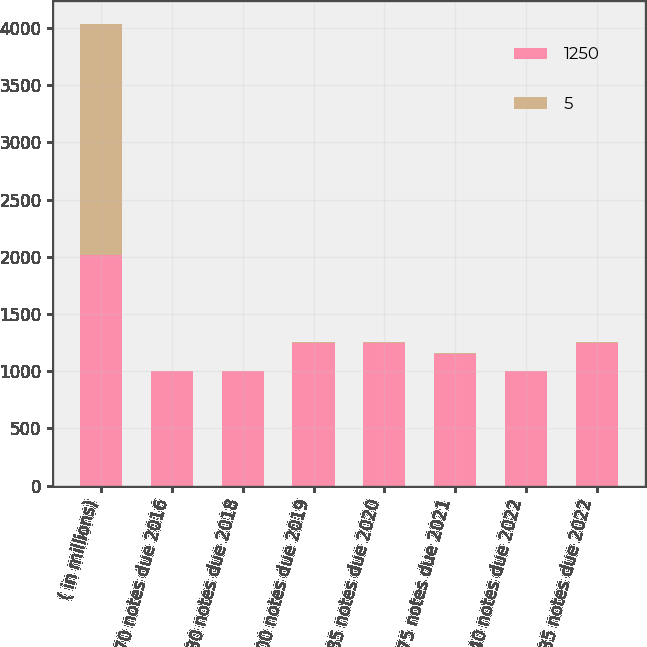<chart> <loc_0><loc_0><loc_500><loc_500><stacked_bar_chart><ecel><fcel>( in millions)<fcel>070 notes due 2016<fcel>130 notes due 2018<fcel>500 notes due 2019<fcel>185 notes due 2020<fcel>3875 notes due 2021<fcel>240 notes due 2022<fcel>235 notes due 2022<nl><fcel>1250<fcel>2015<fcel>1000<fcel>1000<fcel>1250<fcel>1250<fcel>1150<fcel>1000<fcel>1250<nl><fcel>5<fcel>2015<fcel>4<fcel>4<fcel>3<fcel>5<fcel>5<fcel>4<fcel>5<nl></chart> 